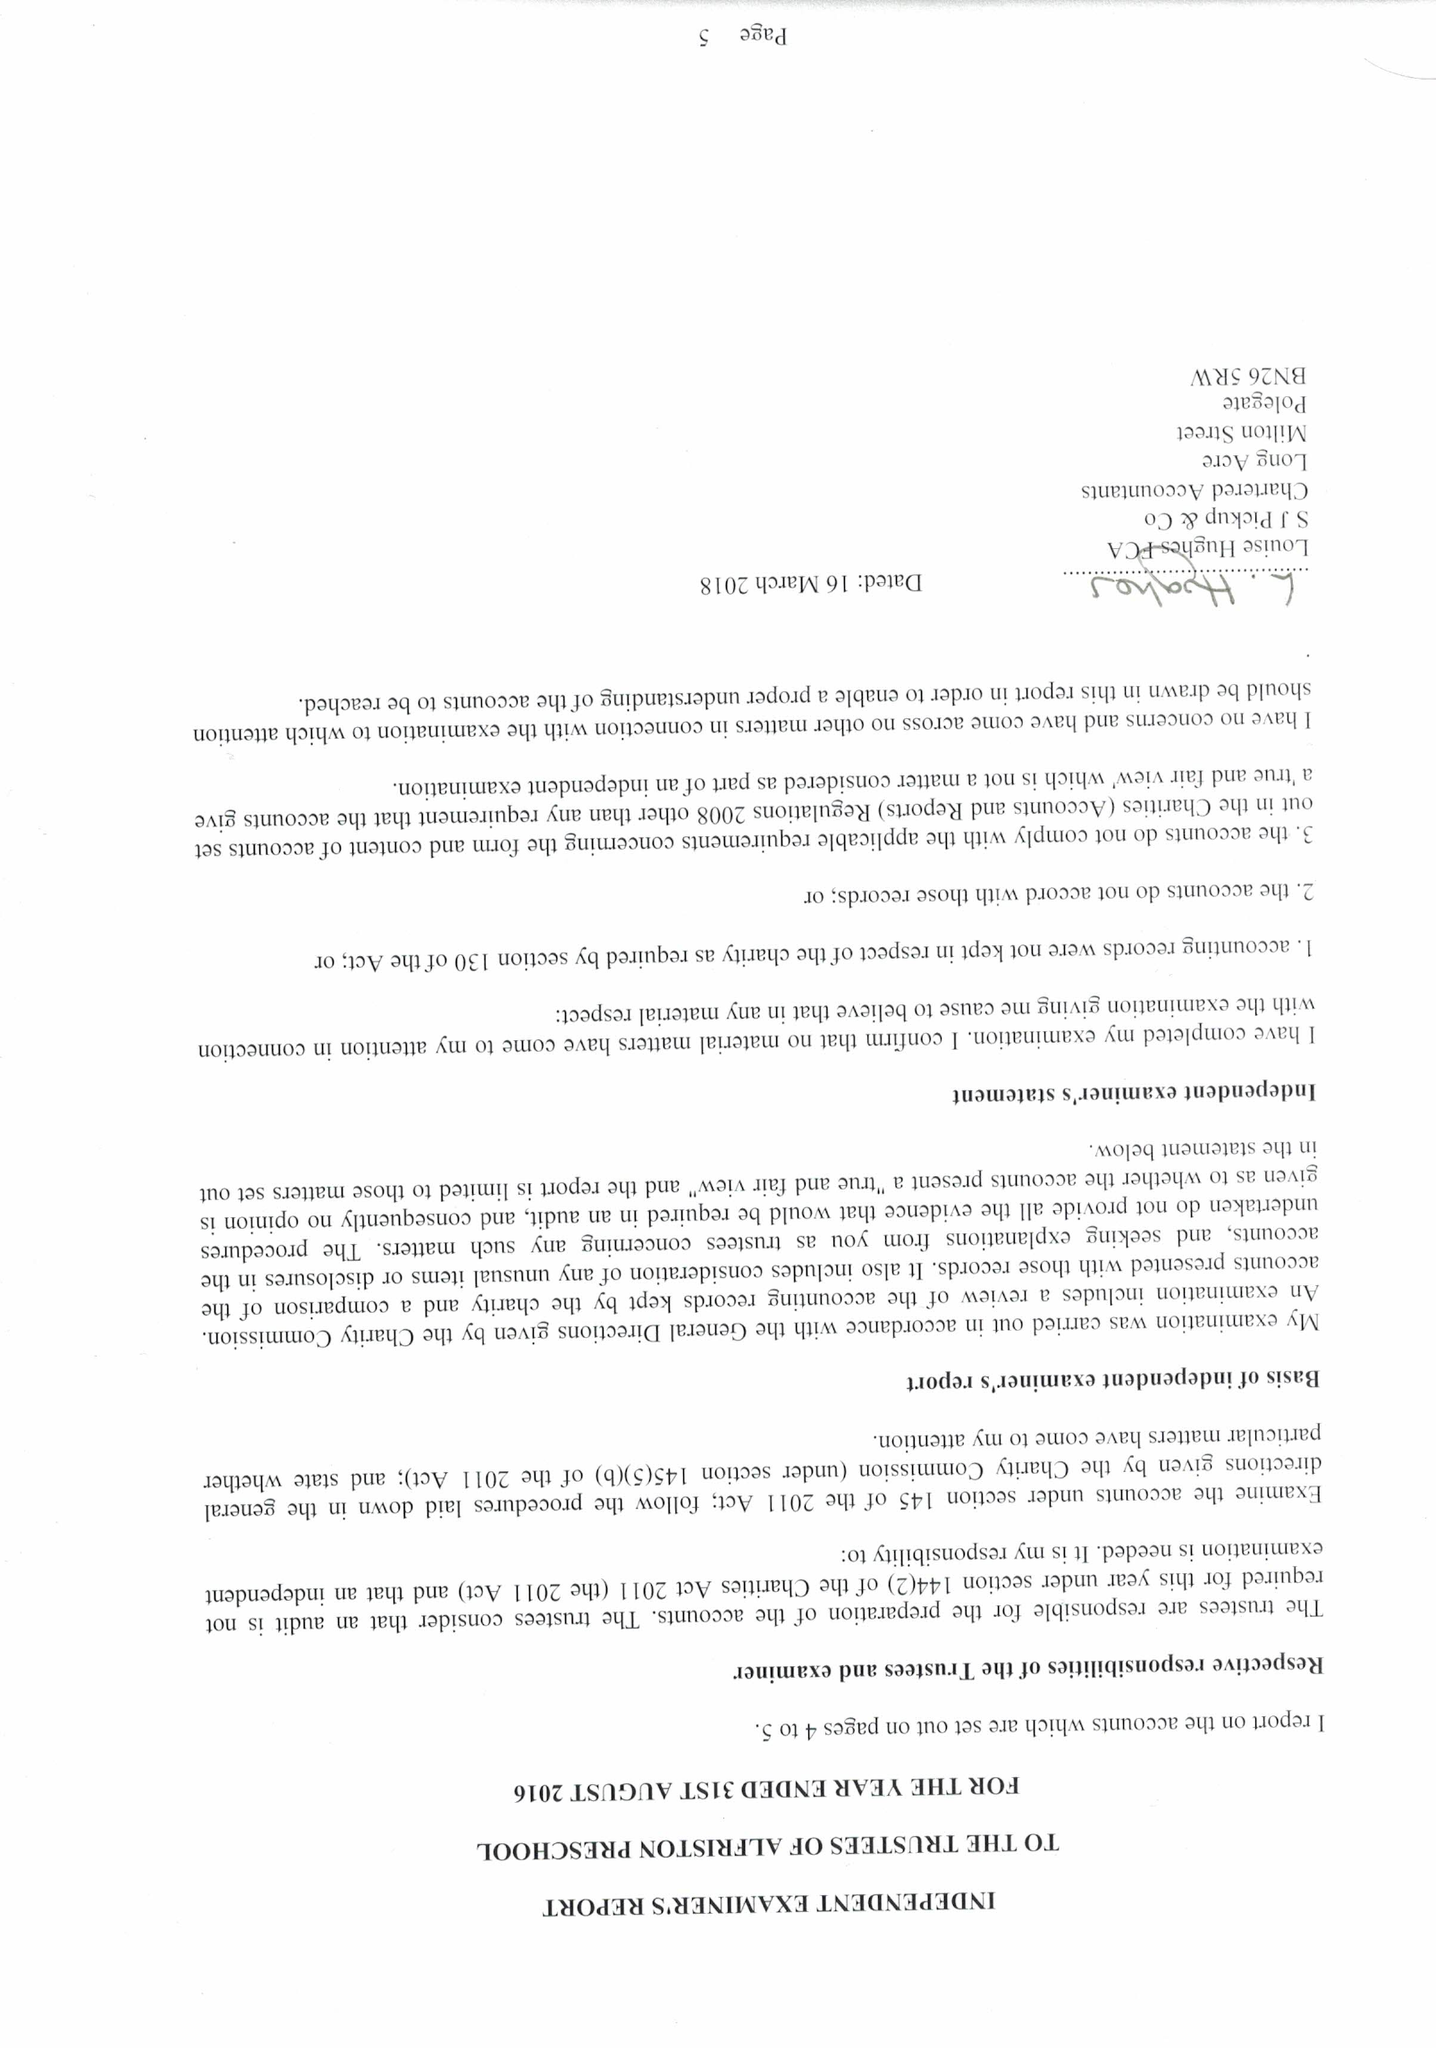What is the value for the spending_annually_in_british_pounds?
Answer the question using a single word or phrase. 60856.00 